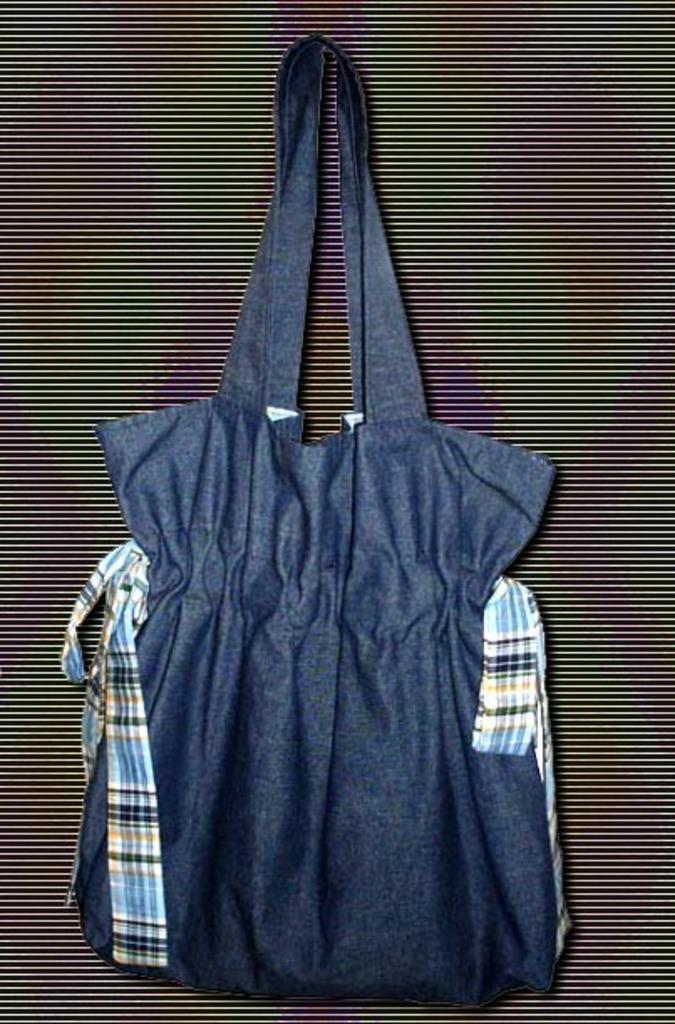What color is the bag that is visible in the image? The bag is blue in the image. Where is the bag located in the image? The bag is hanging on the wall in the image. What type of army equipment can be seen on the stage in the image? There is no army equipment or stage present in the image; it only features a blue color bag hanging on the wall. What ingredients are used to make the eggnog in the image? There is no eggnog present in the image; it only features a blue color bag hanging on the wall. 